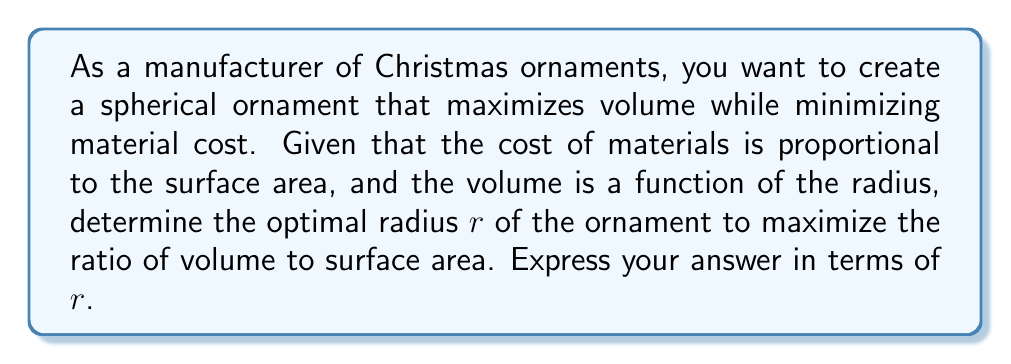Teach me how to tackle this problem. Let's approach this step-by-step:

1) First, recall the formulas for the volume and surface area of a sphere:
   Volume: $V = \frac{4}{3}\pi r^3$
   Surface Area: $A = 4\pi r^2$

2) We want to maximize the ratio of volume to surface area. Let's call this ratio $R$:
   
   $$R = \frac{V}{A} = \frac{\frac{4}{3}\pi r^3}{4\pi r^2} = \frac{r}{3}$$

3) To find the maximum value of $R$, we would typically take the derivative and set it to zero. However, in this case, $R$ is directly proportional to $r$. This means that as $r$ increases, $R$ will always increase.

4) However, we can't make $r$ infinitely large due to practical constraints. The question is asking for the optimal radius, which in this case means the largest practical radius.

5) From a manufacturing standpoint, the largest practical radius would be determined by factors such as:
   - The size of the manufacturing equipment
   - Storage and shipping considerations
   - Consumer preferences for ornament sizes

6) Therefore, the optimal radius $r$ would be the largest radius that is practical given these constraints.

7) The ratio of volume to surface area at this optimal radius would be $\frac{r}{3}$.
Answer: $\frac{r}{3}$, where $r$ is the largest practical radius 